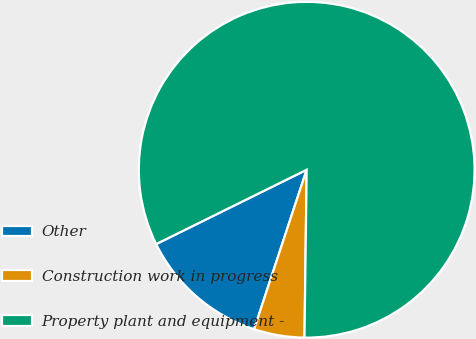Convert chart. <chart><loc_0><loc_0><loc_500><loc_500><pie_chart><fcel>Other<fcel>Construction work in progress<fcel>Property plant and equipment -<nl><fcel>12.63%<fcel>4.86%<fcel>82.51%<nl></chart> 